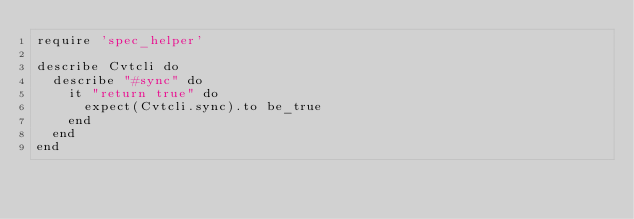<code> <loc_0><loc_0><loc_500><loc_500><_Ruby_>require 'spec_helper'

describe Cvtcli do
  describe "#sync" do
    it "return true" do
      expect(Cvtcli.sync).to be_true
    end
  end
end
</code> 